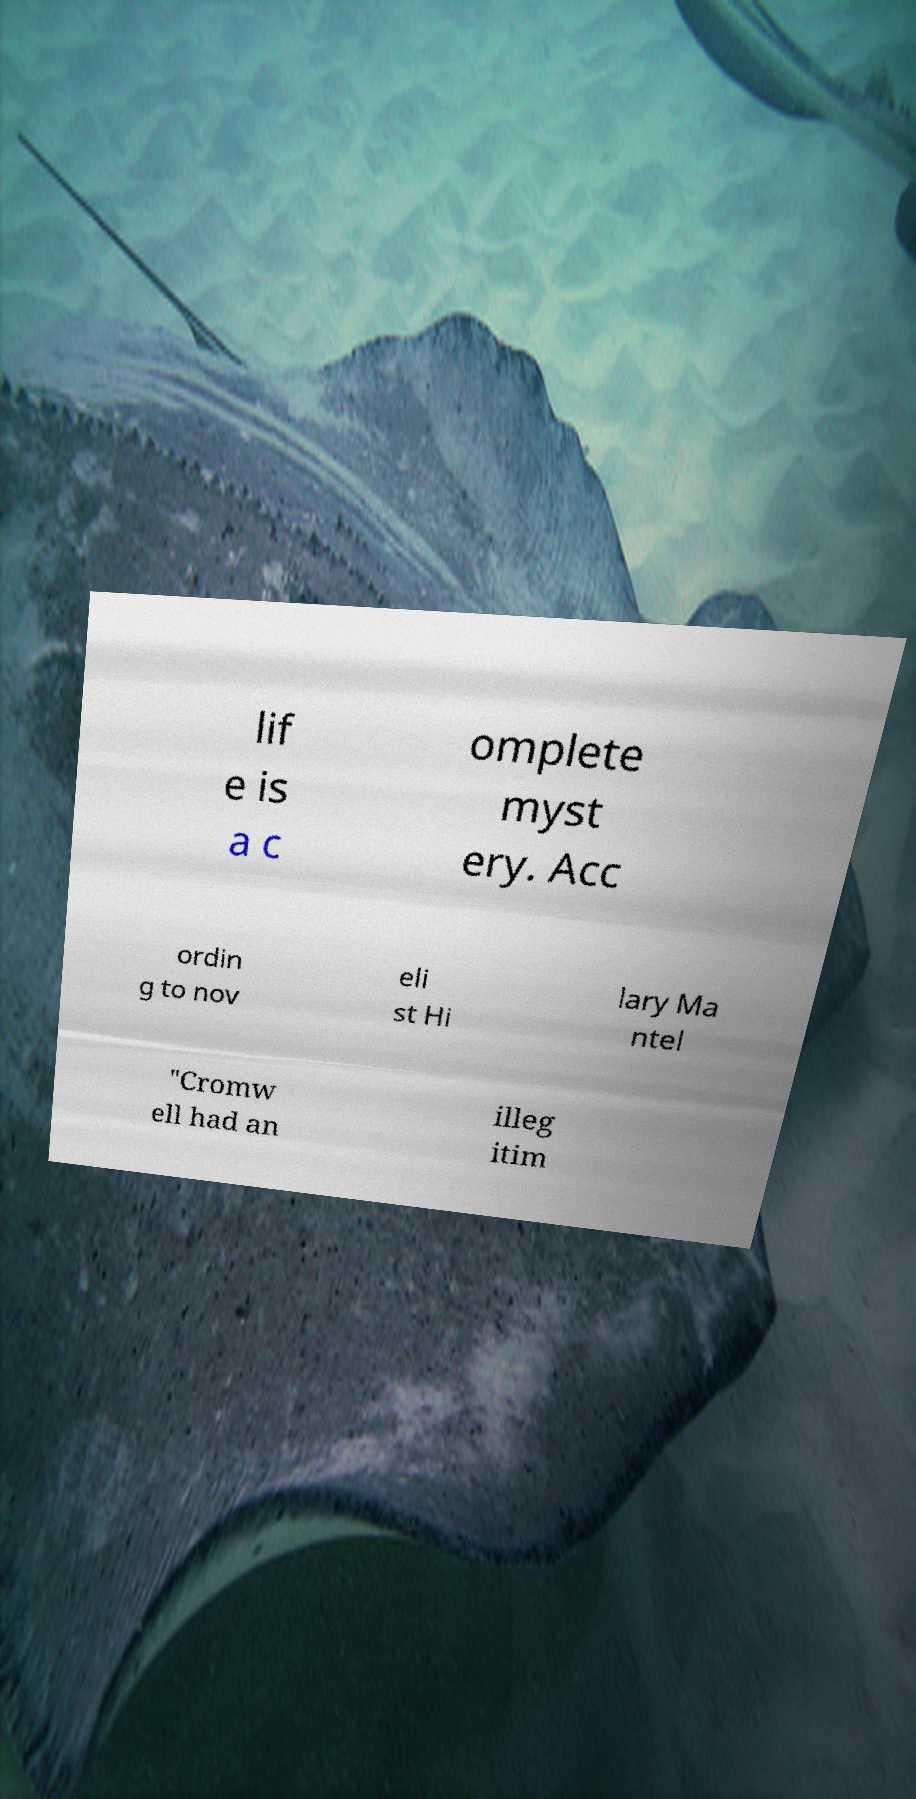Can you accurately transcribe the text from the provided image for me? lif e is a c omplete myst ery. Acc ordin g to nov eli st Hi lary Ma ntel "Cromw ell had an illeg itim 